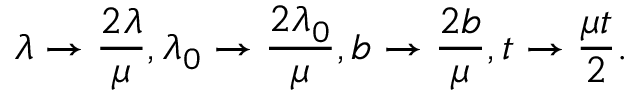<formula> <loc_0><loc_0><loc_500><loc_500>\lambda \to \frac { 2 \lambda } { \mu } , \lambda _ { 0 } \to \frac { 2 \lambda _ { 0 } } { \mu } , b \to \frac { 2 b } { \mu } , t \to \frac { \mu t } { 2 } .</formula> 